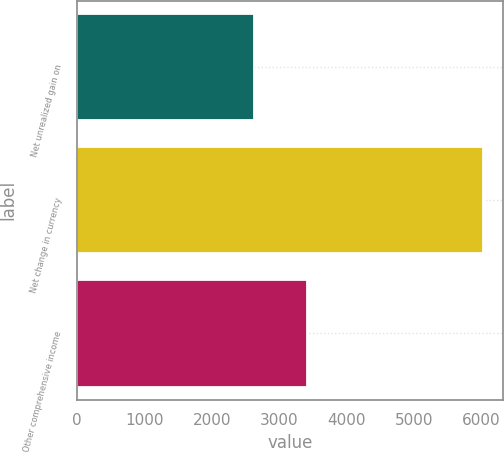<chart> <loc_0><loc_0><loc_500><loc_500><bar_chart><fcel>Net unrealized gain on<fcel>Net change in currency<fcel>Other comprehensive income<nl><fcel>2621<fcel>6029<fcel>3408<nl></chart> 